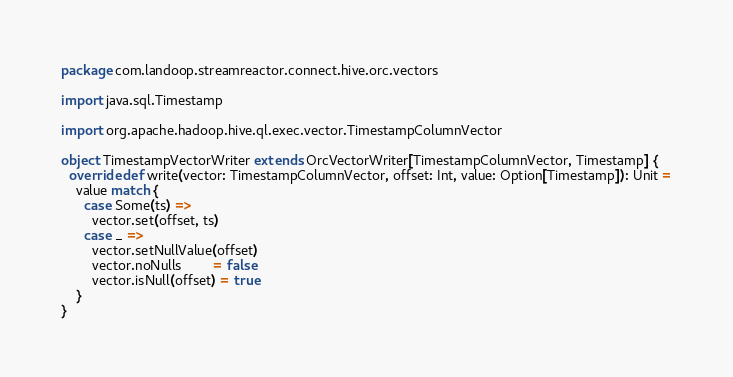Convert code to text. <code><loc_0><loc_0><loc_500><loc_500><_Scala_>package com.landoop.streamreactor.connect.hive.orc.vectors

import java.sql.Timestamp

import org.apache.hadoop.hive.ql.exec.vector.TimestampColumnVector

object TimestampVectorWriter extends OrcVectorWriter[TimestampColumnVector, Timestamp] {
  override def write(vector: TimestampColumnVector, offset: Int, value: Option[Timestamp]): Unit =
    value match {
      case Some(ts) =>
        vector.set(offset, ts)
      case _ =>
        vector.setNullValue(offset)
        vector.noNulls        = false
        vector.isNull(offset) = true
    }
}
</code> 